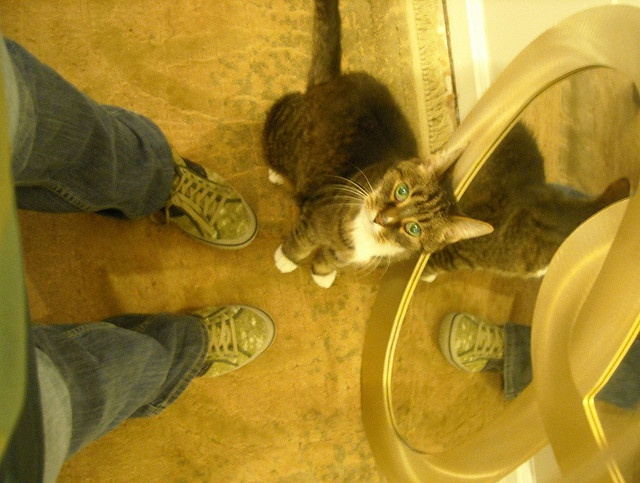Describe the objects in this image and their specific colors. I can see people in olive and black tones and cat in olive, maroon, and black tones in this image. 